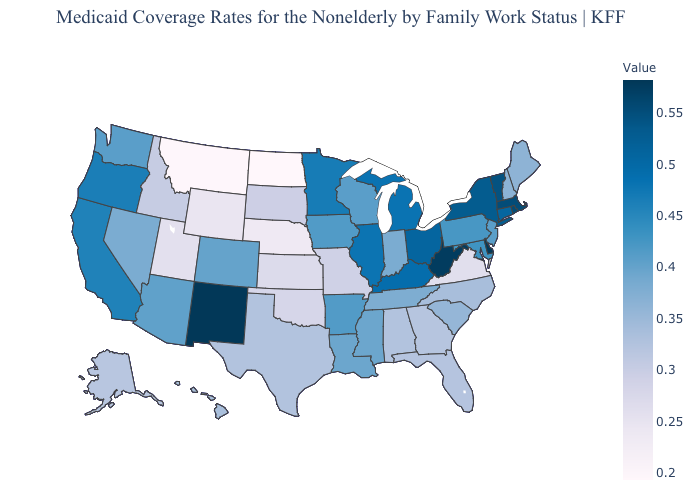Does New Mexico have the highest value in the USA?
Answer briefly. Yes. Is the legend a continuous bar?
Short answer required. Yes. Which states have the lowest value in the USA?
Concise answer only. North Dakota. Among the states that border Montana , which have the highest value?
Answer briefly. Idaho. Does Montana have the lowest value in the West?
Short answer required. Yes. Does North Dakota have the lowest value in the USA?
Quick response, please. Yes. Does North Dakota have the lowest value in the USA?
Concise answer only. Yes. 